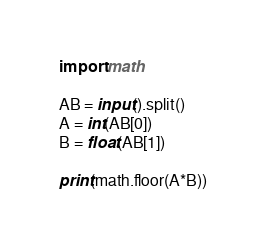Convert code to text. <code><loc_0><loc_0><loc_500><loc_500><_Python_>import math

AB = input().split()
A = int(AB[0])
B = float(AB[1])

print(math.floor(A*B))
</code> 